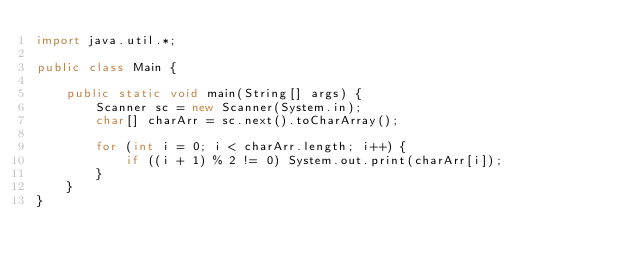Convert code to text. <code><loc_0><loc_0><loc_500><loc_500><_Java_>import java.util.*;

public class Main {

    public static void main(String[] args) {
        Scanner sc = new Scanner(System.in);
        char[] charArr = sc.next().toCharArray();

        for (int i = 0; i < charArr.length; i++) {
            if ((i + 1) % 2 != 0) System.out.print(charArr[i]);
        }
    }
}
</code> 